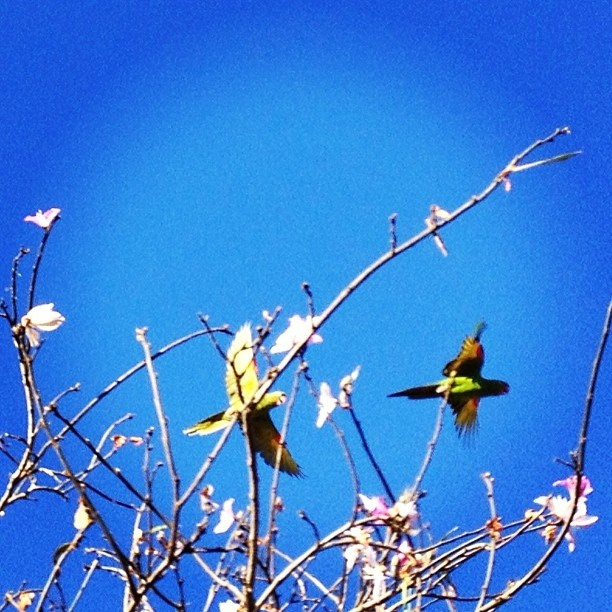Describe the objects in this image and their specific colors. I can see bird in blue, black, gray, and lightblue tones and bird in blue, black, beige, khaki, and maroon tones in this image. 